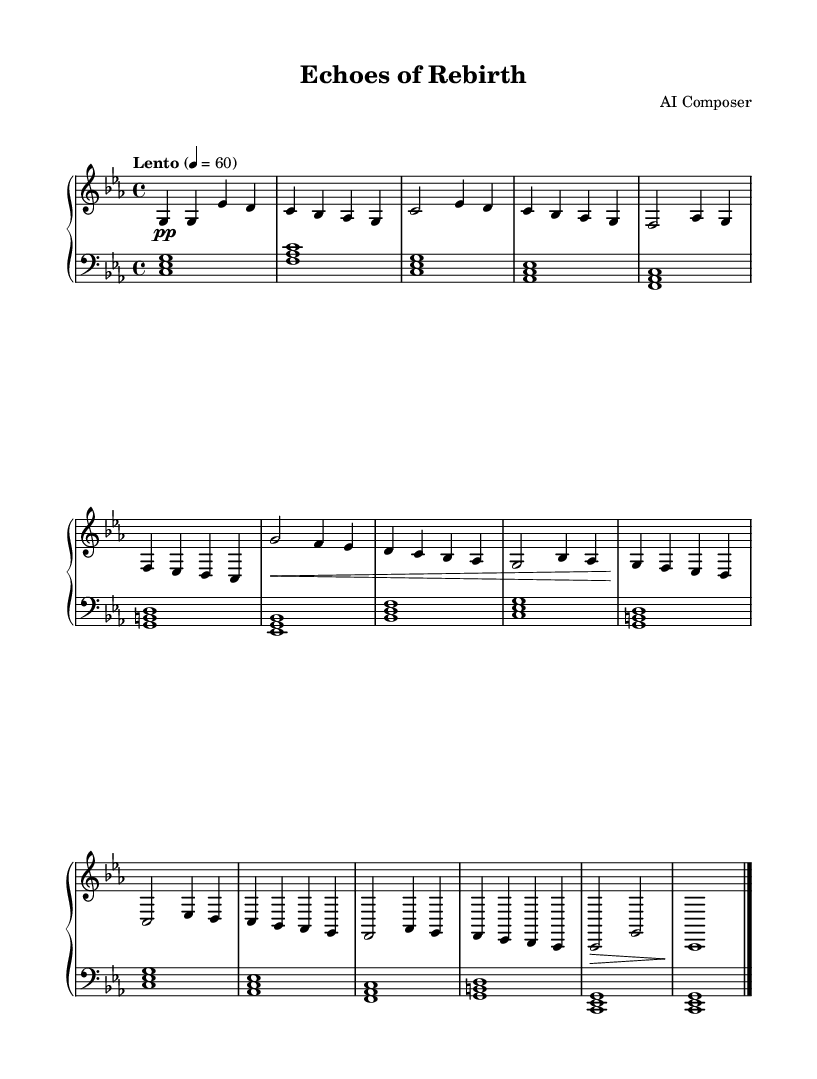What is the key signature of this music? The key signature is C minor, which consists of three flats (B flat, E flat, and A flat). This can be determined by looking at the key signature indicated at the beginning of the score.
Answer: C minor What is the time signature of the piece? The time signature is 4/4, which means there are four beats per measure, and each beat is a quarter note. This is explicitly noted at the start of the staff notation.
Answer: 4/4 What is the tempo marking given for this piece? The tempo marking is "Lento," which indicates a slow pace, and is typically understood as a tempo of around 60 beats per minute, as specified.
Answer: Lento How many measures are in section A of the piece? Section A contains a total of 8 measures. This can be counted by locating the section labeled "A" and tallying the measures from the music notation provided.
Answer: 8 measures What kind of dynamics are indicated for the outro section? The dynamics indicated for the outro section are forte (marked by the symbol 'f'), which means to play loudly. This is determined by analyzing the dynamics marking at the end of the score.
Answer: Forte What is the primary motif in section B? The primary motif in section B consists of a descending melody starting from G. Analyzing the notes in this section reveals that it emphasizes a stepwise motion downward, characterized by the notes given.
Answer: Descending melody 